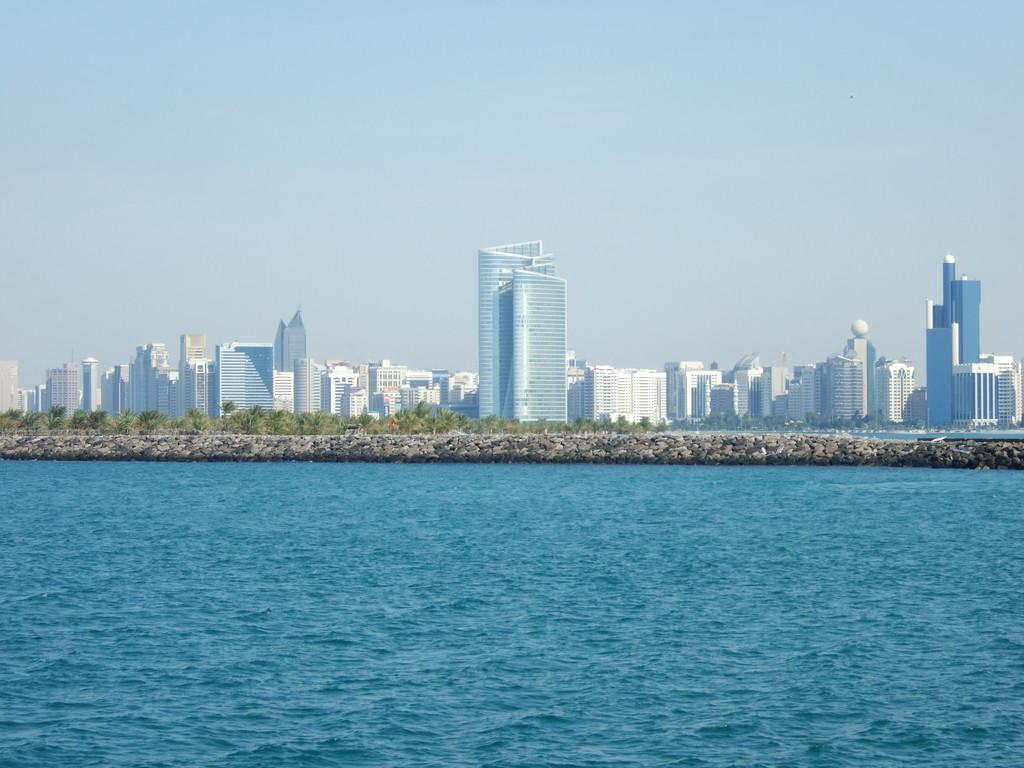Can you describe this image briefly? In this picture I can see water, rocks, trees, buildings, and in the background there is sky. 